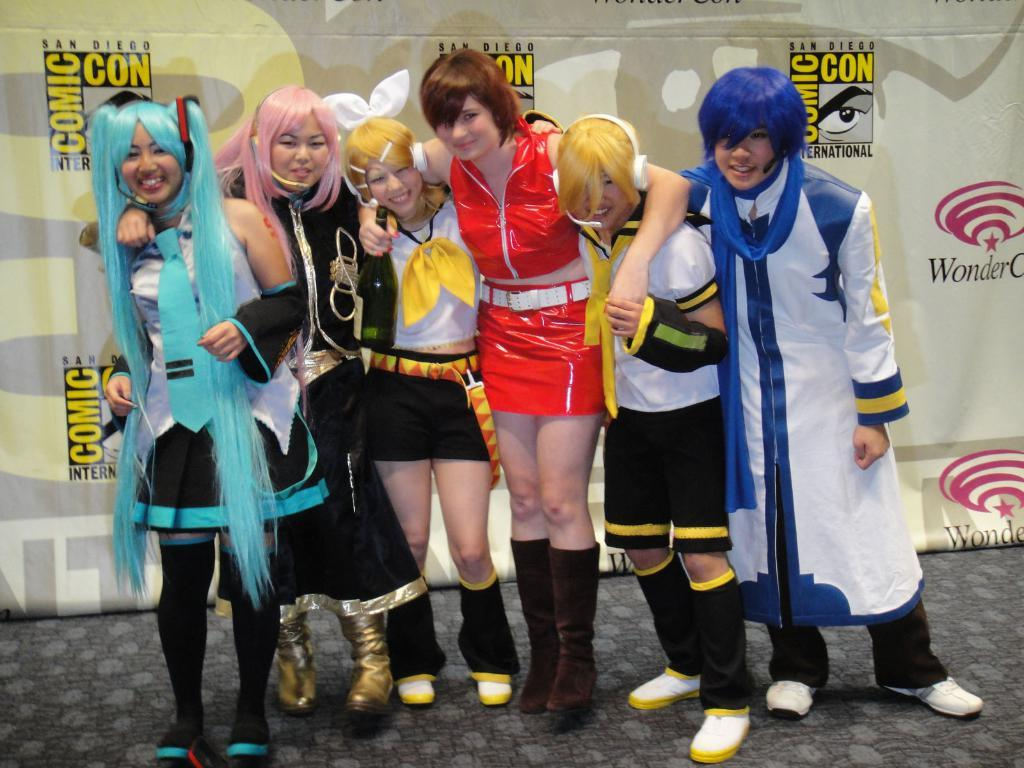<image>
Relay a brief, clear account of the picture shown. A group of comic con attendees dressed in costumes are standing by a wall that says San Diego Comic Con. 